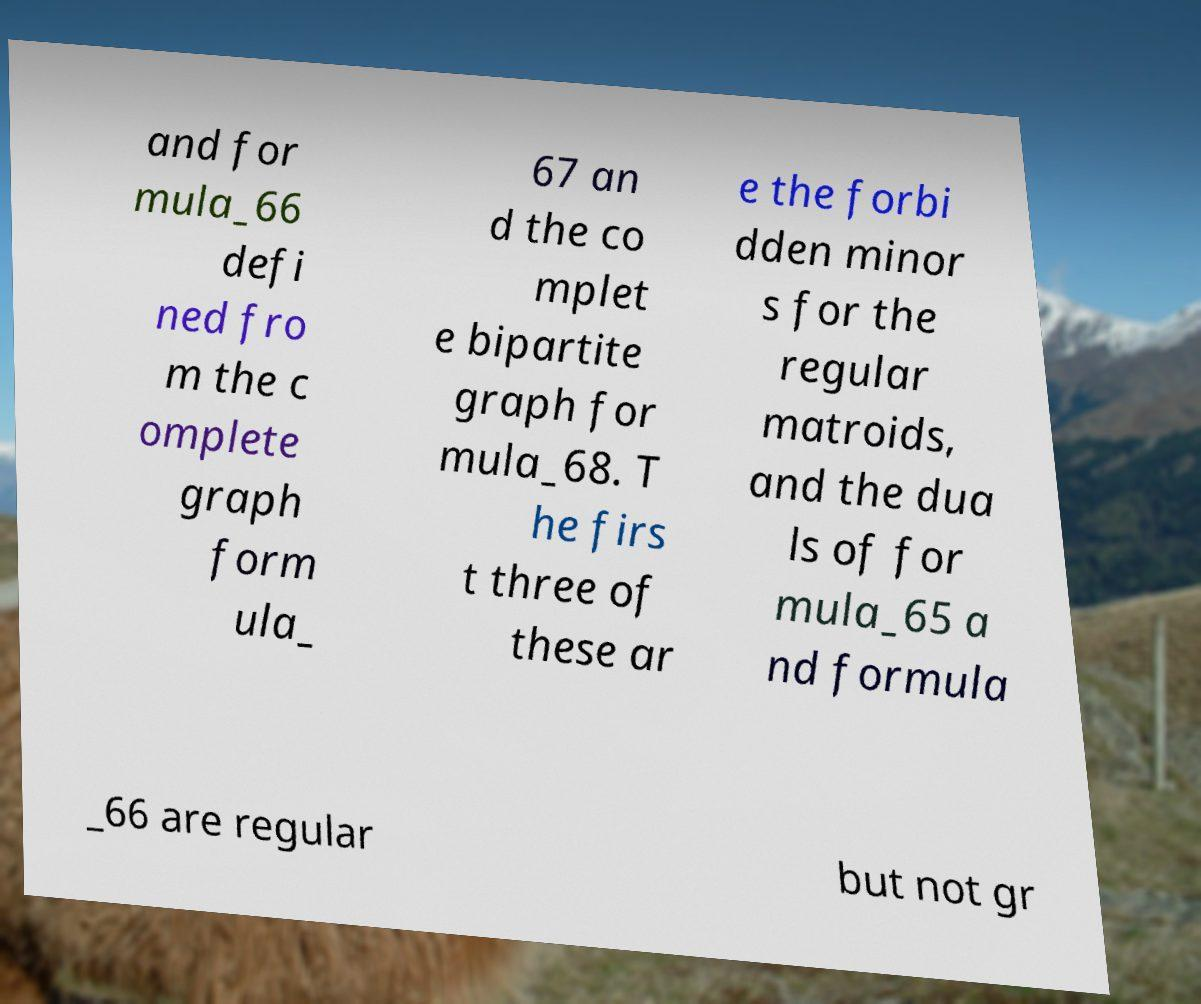Please identify and transcribe the text found in this image. and for mula_66 defi ned fro m the c omplete graph form ula_ 67 an d the co mplet e bipartite graph for mula_68. T he firs t three of these ar e the forbi dden minor s for the regular matroids, and the dua ls of for mula_65 a nd formula _66 are regular but not gr 